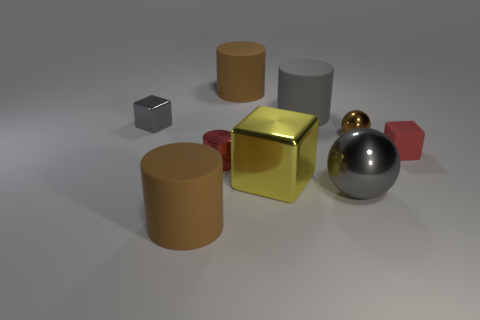What shape is the tiny object that is the same color as the metal cylinder?
Offer a very short reply. Cube. Does the small shiny thing that is in front of the red matte block have the same color as the small block to the right of the tiny red metal cylinder?
Give a very brief answer. Yes. What number of brown objects are on the left side of the large gray metal object and in front of the small gray block?
Offer a terse response. 1. What material is the red cube?
Make the answer very short. Rubber. There is a yellow object that is the same size as the gray matte cylinder; what shape is it?
Give a very brief answer. Cube. Does the big brown thing that is behind the tiny gray cube have the same material as the tiny sphere behind the yellow object?
Your response must be concise. No. How many matte blocks are there?
Your answer should be compact. 1. How many tiny brown metallic things have the same shape as the yellow metal object?
Keep it short and to the point. 0. Does the yellow metallic thing have the same shape as the tiny brown object?
Give a very brief answer. No. The yellow cube is what size?
Give a very brief answer. Large. 